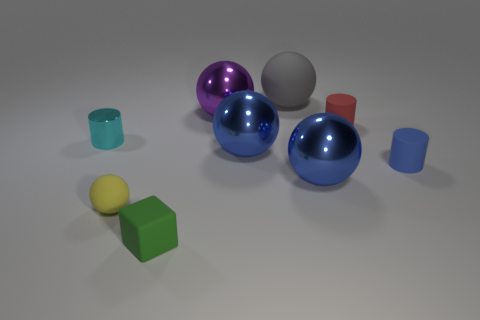Are there any large metallic objects behind the tiny cylinder left of the small green object?
Offer a terse response. Yes. What number of balls are the same material as the small blue cylinder?
Offer a terse response. 2. There is a blue metal sphere that is right of the big object behind the metal thing behind the tiny red cylinder; how big is it?
Give a very brief answer. Large. What number of small yellow rubber spheres are behind the tiny blue thing?
Your answer should be very brief. 0. Are there more blue objects than objects?
Your answer should be very brief. No. What is the size of the matte object that is both right of the large purple metallic thing and in front of the small red rubber cylinder?
Give a very brief answer. Small. There is a tiny blue thing that is in front of the big blue thing that is behind the tiny object that is to the right of the red thing; what is its material?
Your answer should be compact. Rubber. There is a tiny rubber object that is left of the small block; does it have the same color as the big sphere that is behind the purple object?
Provide a succinct answer. No. There is a large blue shiny object on the left side of the metal sphere that is in front of the big blue shiny object that is on the left side of the gray matte thing; what is its shape?
Your response must be concise. Sphere. There is a big thing that is on the right side of the large purple thing and behind the cyan thing; what is its shape?
Your response must be concise. Sphere. 